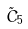Convert formula to latex. <formula><loc_0><loc_0><loc_500><loc_500>\tilde { C } _ { 5 }</formula> 